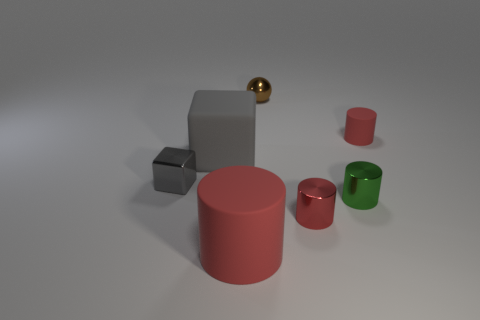Subtract all red cylinders. How many were subtracted if there are1red cylinders left? 2 Subtract all red cylinders. How many cylinders are left? 1 Subtract all green cylinders. How many cylinders are left? 3 Add 1 red shiny things. How many objects exist? 8 Subtract 0 blue balls. How many objects are left? 7 Subtract all cubes. How many objects are left? 5 Subtract 2 cylinders. How many cylinders are left? 2 Subtract all cyan spheres. Subtract all blue blocks. How many spheres are left? 1 Subtract all brown balls. How many green cylinders are left? 1 Subtract all tiny cylinders. Subtract all large cyan metal cylinders. How many objects are left? 4 